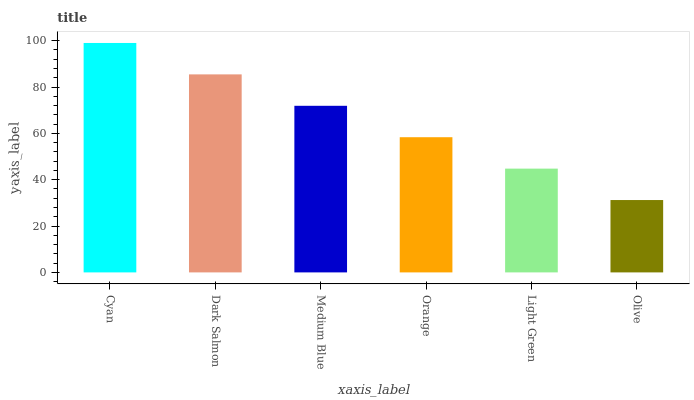Is Dark Salmon the minimum?
Answer yes or no. No. Is Dark Salmon the maximum?
Answer yes or no. No. Is Cyan greater than Dark Salmon?
Answer yes or no. Yes. Is Dark Salmon less than Cyan?
Answer yes or no. Yes. Is Dark Salmon greater than Cyan?
Answer yes or no. No. Is Cyan less than Dark Salmon?
Answer yes or no. No. Is Medium Blue the high median?
Answer yes or no. Yes. Is Orange the low median?
Answer yes or no. Yes. Is Dark Salmon the high median?
Answer yes or no. No. Is Dark Salmon the low median?
Answer yes or no. No. 